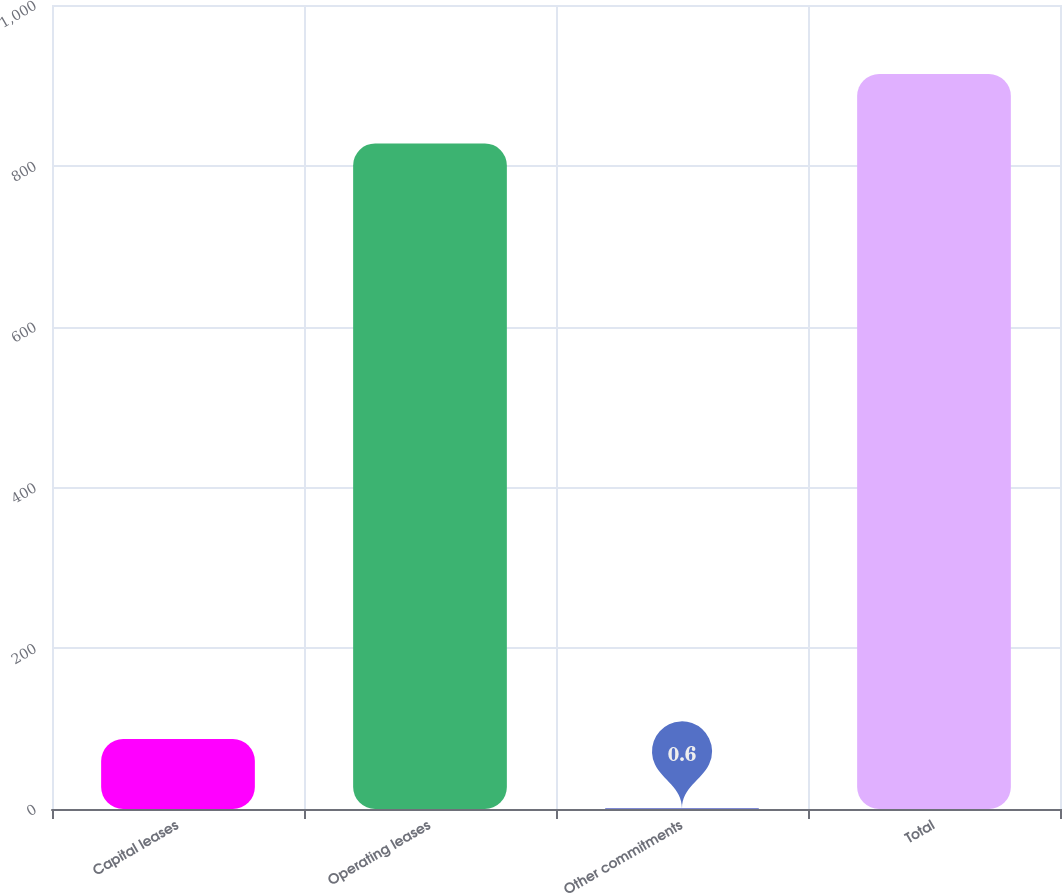Convert chart to OTSL. <chart><loc_0><loc_0><loc_500><loc_500><bar_chart><fcel>Capital leases<fcel>Operating leases<fcel>Other commitments<fcel>Total<nl><fcel>86.93<fcel>827.8<fcel>0.6<fcel>914.13<nl></chart> 